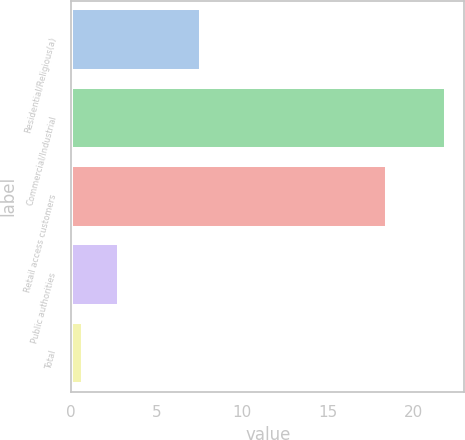Convert chart to OTSL. <chart><loc_0><loc_0><loc_500><loc_500><bar_chart><fcel>Residential/Religious(a)<fcel>Commercial/Industrial<fcel>Retail access customers<fcel>Public authorities<fcel>Total<nl><fcel>7.6<fcel>21.9<fcel>18.5<fcel>2.82<fcel>0.7<nl></chart> 